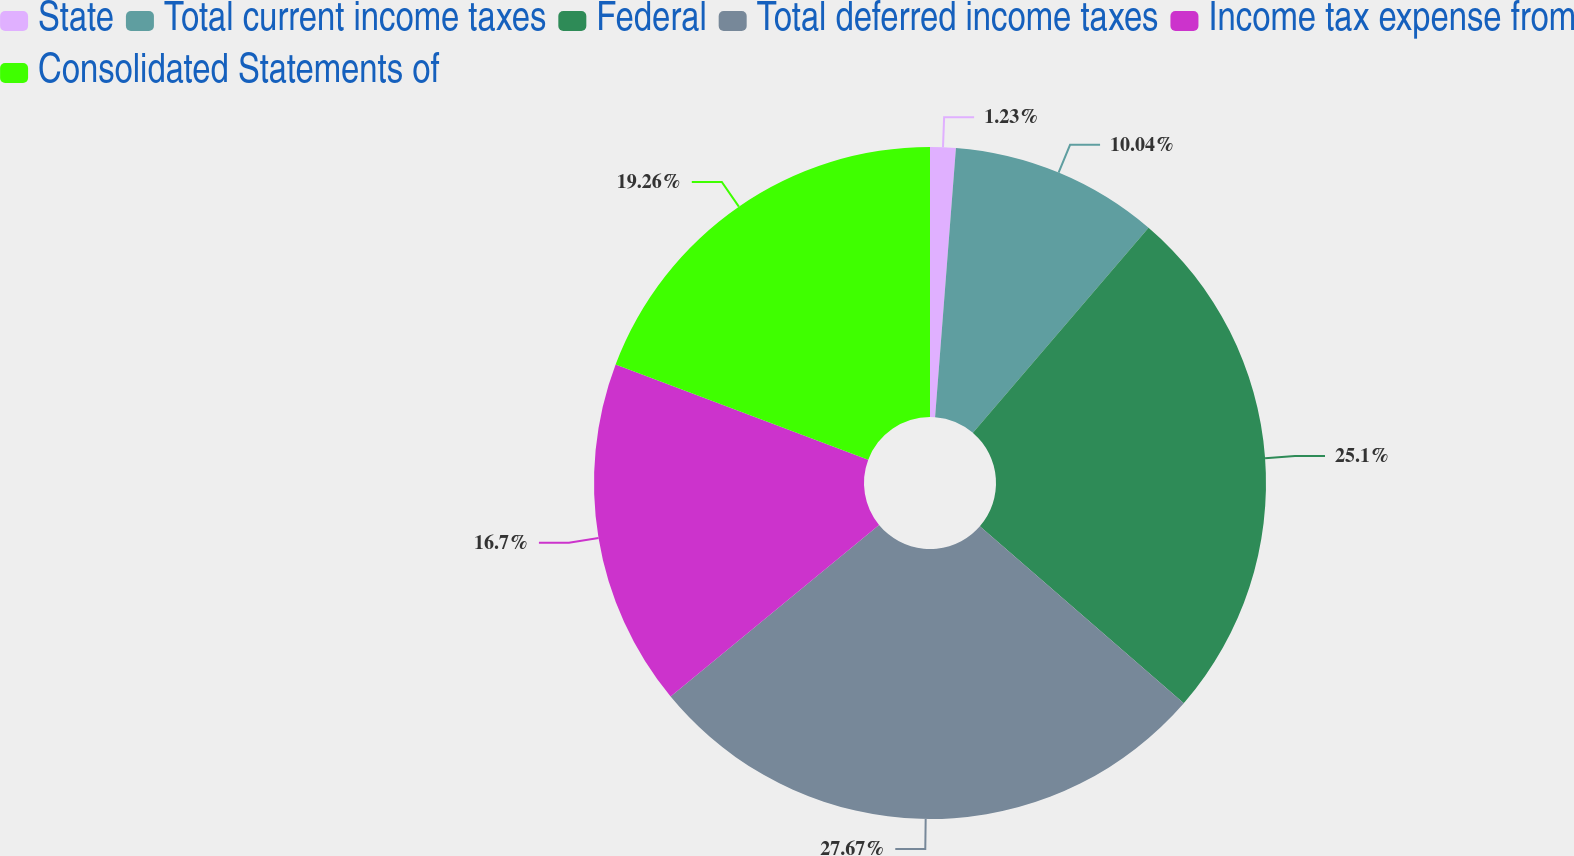<chart> <loc_0><loc_0><loc_500><loc_500><pie_chart><fcel>State<fcel>Total current income taxes<fcel>Federal<fcel>Total deferred income taxes<fcel>Income tax expense from<fcel>Consolidated Statements of<nl><fcel>1.23%<fcel>10.04%<fcel>25.1%<fcel>27.66%<fcel>16.7%<fcel>19.26%<nl></chart> 